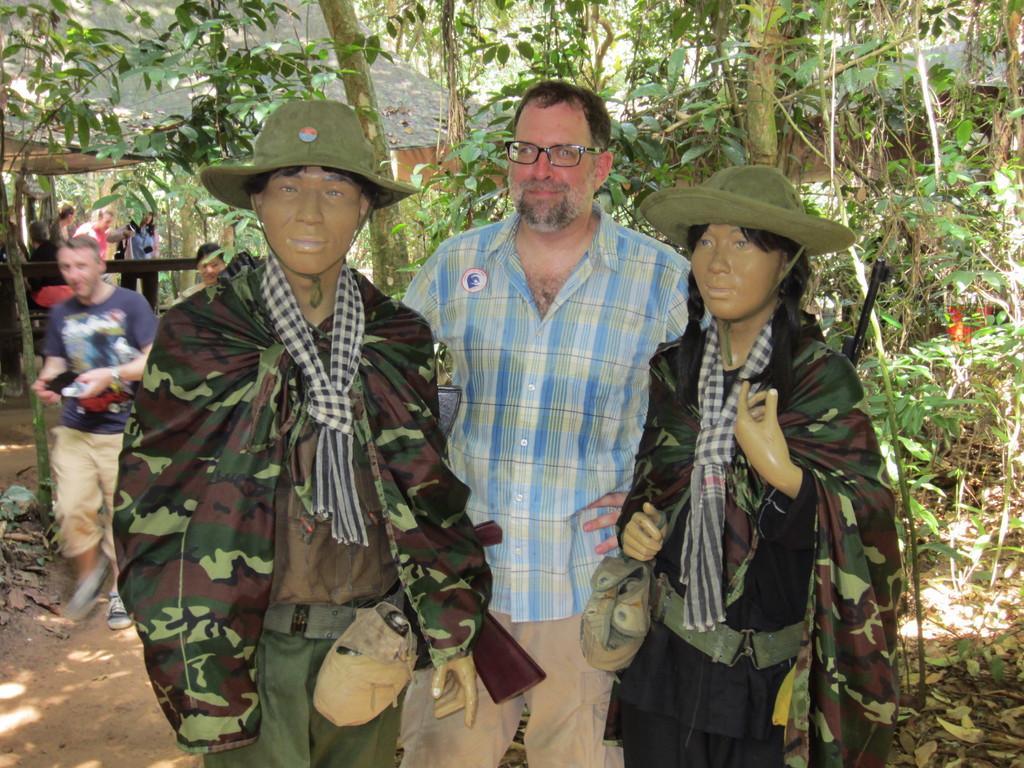How would you summarize this image in a sentence or two? On the left side, there is a person´s statue who is wearing a green color cap, smiling and standing. Beside this person, there is another person wearing a spectacle, smiling and standing. On the right side, there is a woman´statue, wearing a green color cap, smiling and standing. In the background, there are trees, plants and shelters. 